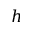Convert formula to latex. <formula><loc_0><loc_0><loc_500><loc_500>h</formula> 